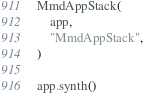<code> <loc_0><loc_0><loc_500><loc_500><_Python_>MmdAppStack(
    app,
    "MmdAppStack",
)

app.synth()
</code> 